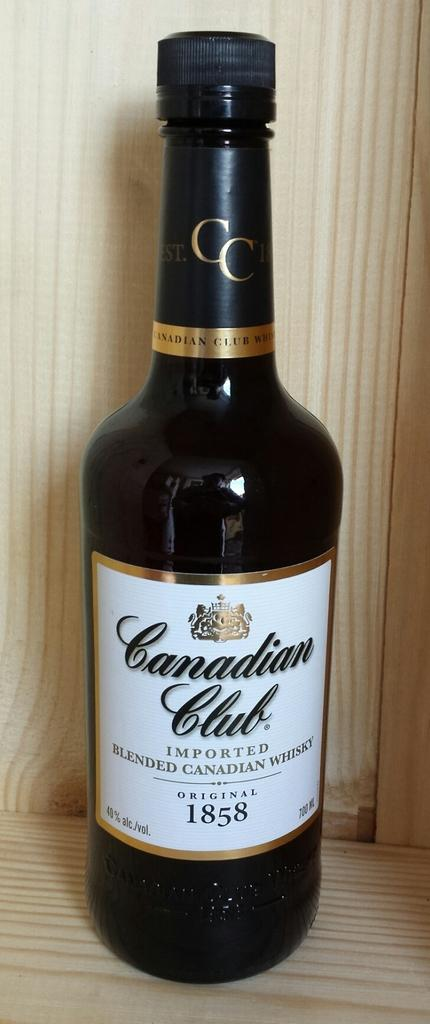<image>
Render a clear and concise summary of the photo. a canadian club wine container on a brown surface 